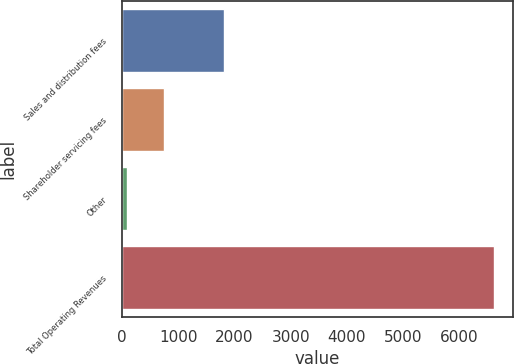Convert chart. <chart><loc_0><loc_0><loc_500><loc_500><bar_chart><fcel>Sales and distribution fees<fcel>Shareholder servicing fees<fcel>Other<fcel>Total Operating Revenues<nl><fcel>1806.4<fcel>748.47<fcel>96.3<fcel>6618<nl></chart> 